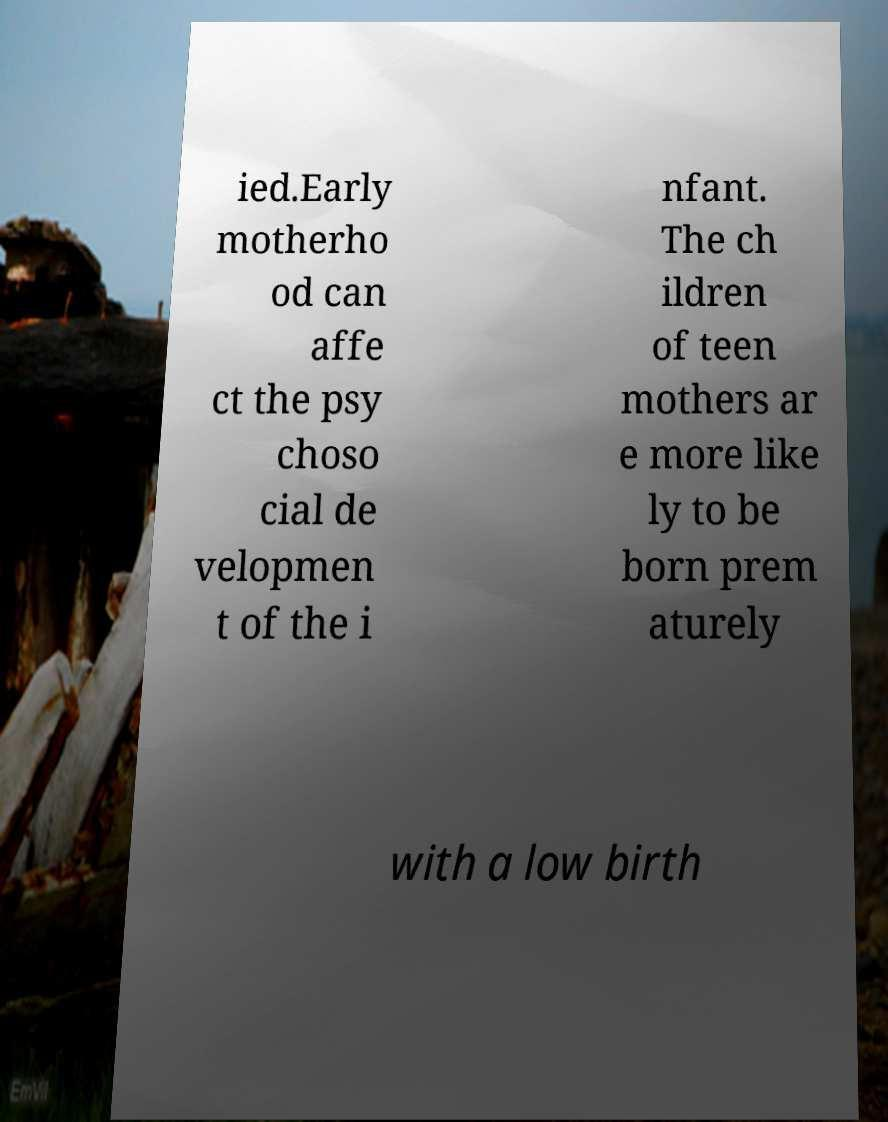Please read and relay the text visible in this image. What does it say? ied.Early motherho od can affe ct the psy choso cial de velopmen t of the i nfant. The ch ildren of teen mothers ar e more like ly to be born prem aturely with a low birth 